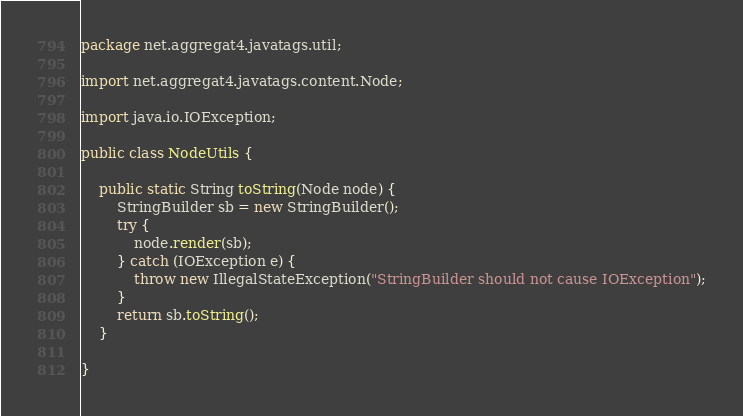<code> <loc_0><loc_0><loc_500><loc_500><_Java_>package net.aggregat4.javatags.util;

import net.aggregat4.javatags.content.Node;

import java.io.IOException;

public class NodeUtils {

    public static String toString(Node node) {
        StringBuilder sb = new StringBuilder();
        try {
            node.render(sb);
        } catch (IOException e) {
            throw new IllegalStateException("StringBuilder should not cause IOException");
        }
        return sb.toString();
    }

}
</code> 